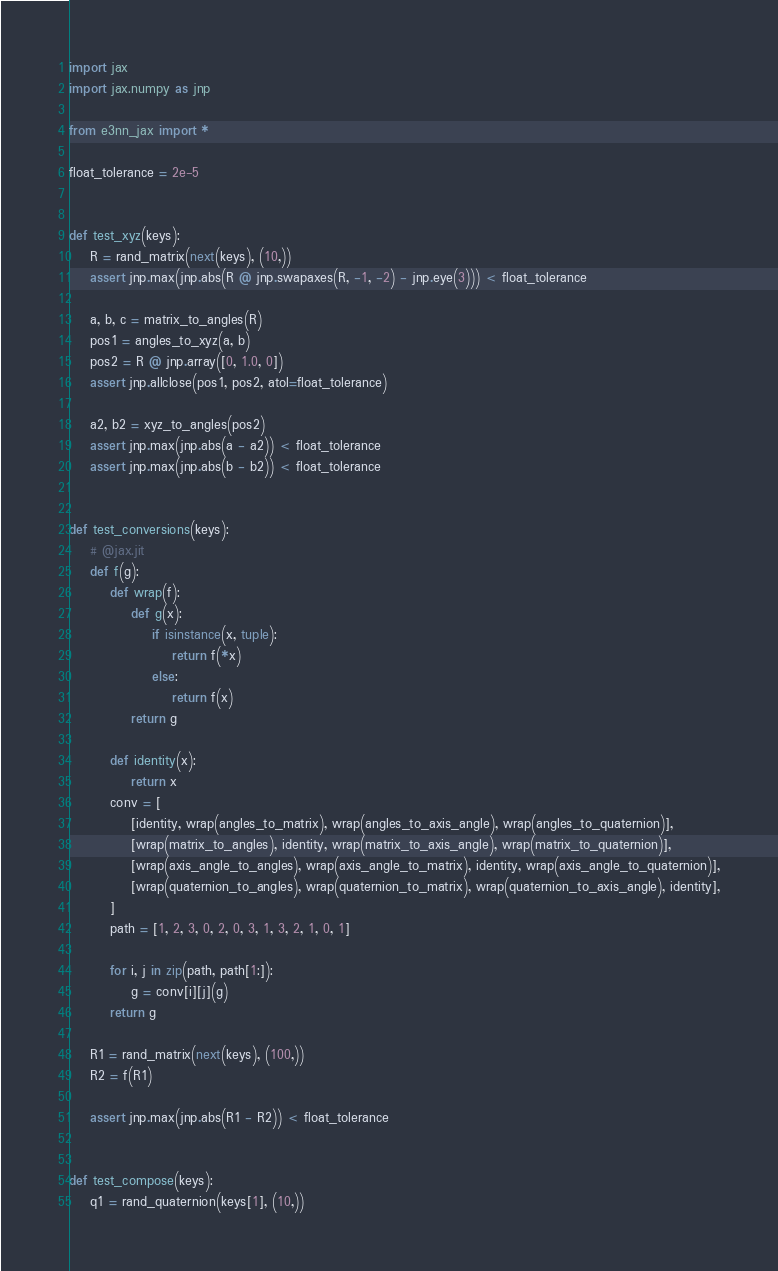<code> <loc_0><loc_0><loc_500><loc_500><_Python_>import jax
import jax.numpy as jnp

from e3nn_jax import *

float_tolerance = 2e-5


def test_xyz(keys):
    R = rand_matrix(next(keys), (10,))
    assert jnp.max(jnp.abs(R @ jnp.swapaxes(R, -1, -2) - jnp.eye(3))) < float_tolerance

    a, b, c = matrix_to_angles(R)
    pos1 = angles_to_xyz(a, b)
    pos2 = R @ jnp.array([0, 1.0, 0])
    assert jnp.allclose(pos1, pos2, atol=float_tolerance)

    a2, b2 = xyz_to_angles(pos2)
    assert jnp.max(jnp.abs(a - a2)) < float_tolerance
    assert jnp.max(jnp.abs(b - b2)) < float_tolerance


def test_conversions(keys):
    # @jax.jit
    def f(g):
        def wrap(f):
            def g(x):
                if isinstance(x, tuple):
                    return f(*x)
                else:
                    return f(x)
            return g

        def identity(x):
            return x
        conv = [
            [identity, wrap(angles_to_matrix), wrap(angles_to_axis_angle), wrap(angles_to_quaternion)],
            [wrap(matrix_to_angles), identity, wrap(matrix_to_axis_angle), wrap(matrix_to_quaternion)],
            [wrap(axis_angle_to_angles), wrap(axis_angle_to_matrix), identity, wrap(axis_angle_to_quaternion)],
            [wrap(quaternion_to_angles), wrap(quaternion_to_matrix), wrap(quaternion_to_axis_angle), identity],
        ]
        path = [1, 2, 3, 0, 2, 0, 3, 1, 3, 2, 1, 0, 1]

        for i, j in zip(path, path[1:]):
            g = conv[i][j](g)
        return g

    R1 = rand_matrix(next(keys), (100,))
    R2 = f(R1)

    assert jnp.max(jnp.abs(R1 - R2)) < float_tolerance


def test_compose(keys):
    q1 = rand_quaternion(keys[1], (10,))</code> 